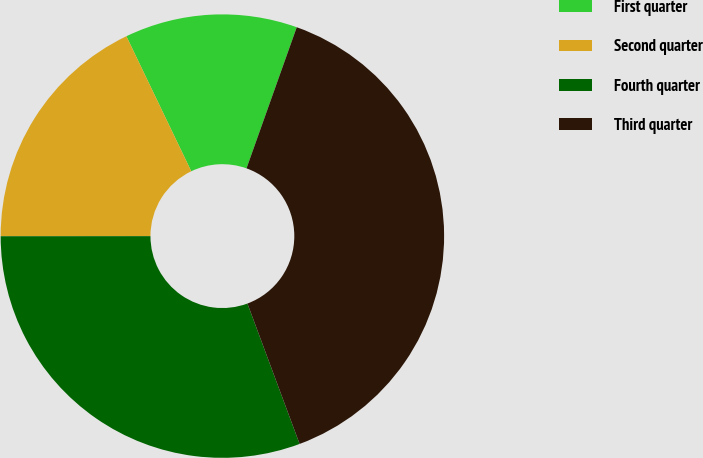<chart> <loc_0><loc_0><loc_500><loc_500><pie_chart><fcel>First quarter<fcel>Second quarter<fcel>Fourth quarter<fcel>Third quarter<nl><fcel>12.57%<fcel>17.88%<fcel>30.65%<fcel>38.89%<nl></chart> 